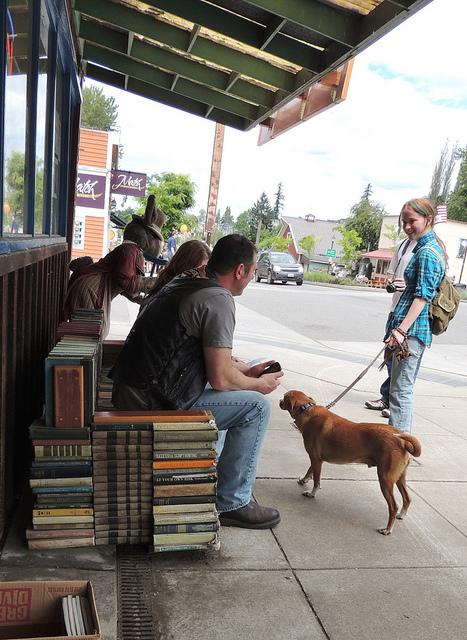From which room could items used to make this chair originate? library 